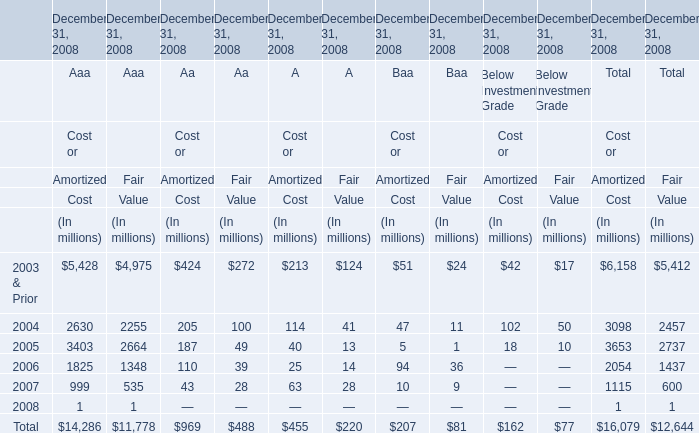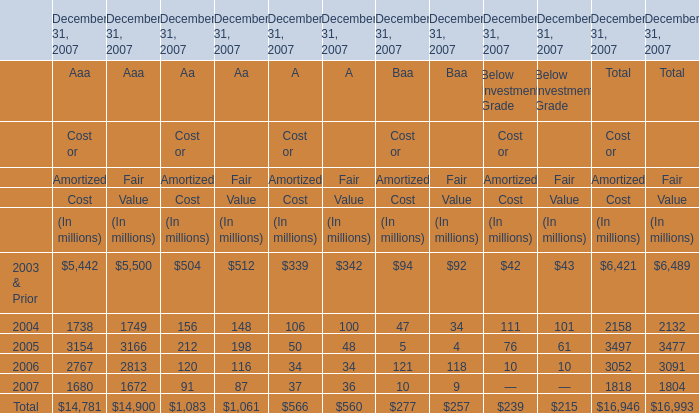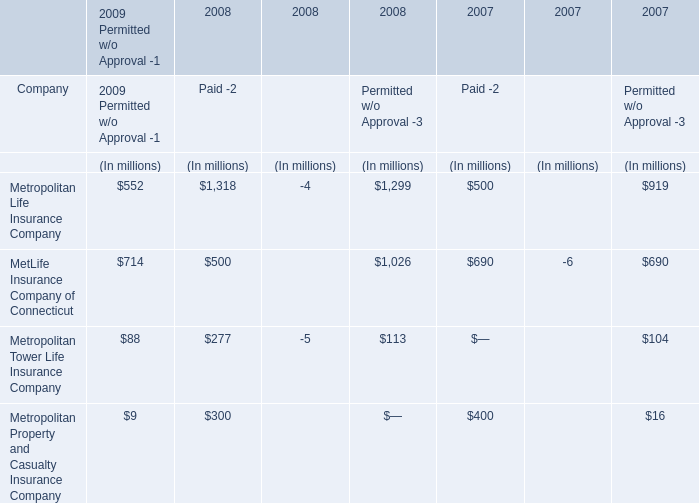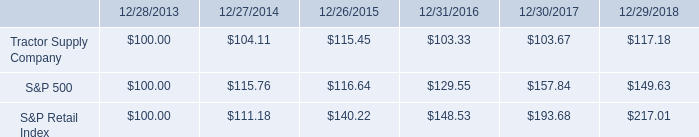What do all Aaa sum up, excluding those negative ones in 2007? (in million) 
Computations: (((((((((5442 + 5500) + 1738) + 1749) + 3154) + 3166) + 2767) + 2813) + 1680) + 1672)
Answer: 29681.0. 